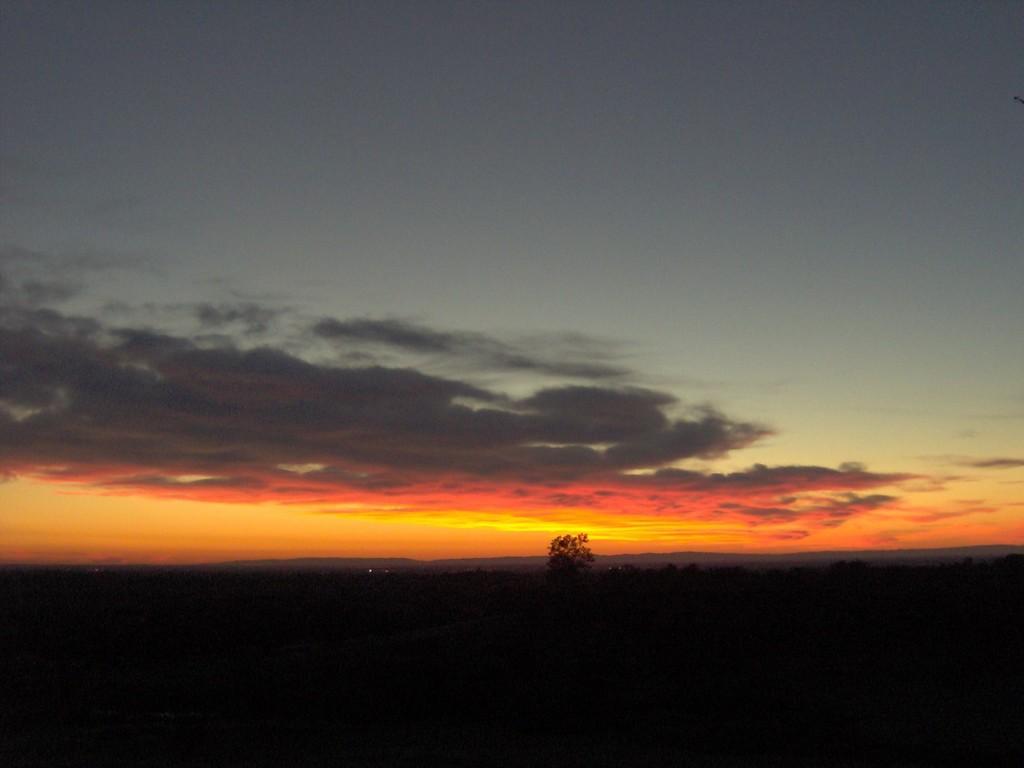Describe this image in one or two sentences. In this picture, we can see the sky with clouds and some plant. 